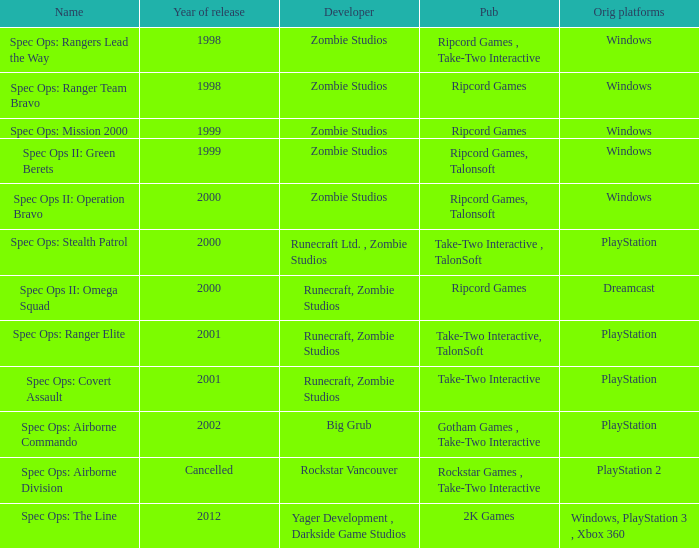Which developer has a year of cancelled releases? Rockstar Vancouver. 